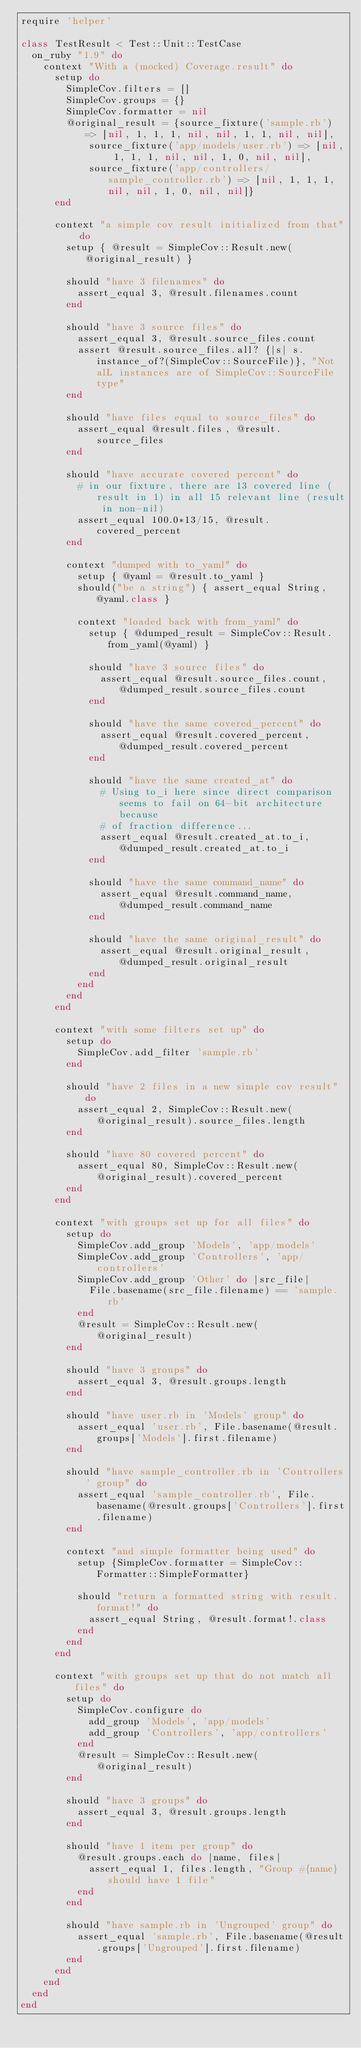<code> <loc_0><loc_0><loc_500><loc_500><_Ruby_>require 'helper'

class TestResult < Test::Unit::TestCase
  on_ruby "1.9" do
    context "With a (mocked) Coverage.result" do
      setup do
        SimpleCov.filters = []
        SimpleCov.groups = {}
        SimpleCov.formatter = nil
        @original_result = {source_fixture('sample.rb') => [nil, 1, 1, 1, nil, nil, 1, 1, nil, nil],
            source_fixture('app/models/user.rb') => [nil, 1, 1, 1, nil, nil, 1, 0, nil, nil],
            source_fixture('app/controllers/sample_controller.rb') => [nil, 1, 1, 1, nil, nil, 1, 0, nil, nil]}
      end
  
      context "a simple cov result initialized from that" do
        setup { @result = SimpleCov::Result.new(@original_result) }
    
        should "have 3 filenames" do
          assert_equal 3, @result.filenames.count
        end
    
        should "have 3 source files" do
          assert_equal 3, @result.source_files.count
          assert @result.source_files.all? {|s| s.instance_of?(SimpleCov::SourceFile)}, "Not alL instances are of SimpleCov::SourceFile type"
        end
    
        should "have files equal to source_files" do
          assert_equal @result.files, @result.source_files
        end
      
        should "have accurate covered percent" do
          # in our fixture, there are 13 covered line (result in 1) in all 15 relevant line (result in non-nil)
          assert_equal 100.0*13/15, @result.covered_percent
        end
      
        context "dumped with to_yaml" do
          setup { @yaml = @result.to_yaml }
          should("be a string") { assert_equal String, @yaml.class }
        
          context "loaded back with from_yaml" do
            setup { @dumped_result = SimpleCov::Result.from_yaml(@yaml) }
          
            should "have 3 source files" do
              assert_equal @result.source_files.count, @dumped_result.source_files.count
            end
          
            should "have the same covered_percent" do
              assert_equal @result.covered_percent, @dumped_result.covered_percent
            end
          
            should "have the same created_at" do
              # Using to_i here since direct comparison seems to fail on 64-bit architecture because
              # of fraction difference...
              assert_equal @result.created_at.to_i, @dumped_result.created_at.to_i
            end
          
            should "have the same command_name" do
              assert_equal @result.command_name, @dumped_result.command_name
            end
          
            should "have the same original_result" do
              assert_equal @result.original_result, @dumped_result.original_result
            end
          end
        end
      end
    
      context "with some filters set up" do
        setup do
          SimpleCov.add_filter 'sample.rb'
        end
      
        should "have 2 files in a new simple cov result" do
          assert_equal 2, SimpleCov::Result.new(@original_result).source_files.length
        end
      
        should "have 80 covered percent" do
          assert_equal 80, SimpleCov::Result.new(@original_result).covered_percent
        end
      end
    
      context "with groups set up for all files" do
        setup do
          SimpleCov.add_group 'Models', 'app/models'
          SimpleCov.add_group 'Controllers', 'app/controllers'
          SimpleCov.add_group 'Other' do |src_file|
            File.basename(src_file.filename) == 'sample.rb'
          end
          @result = SimpleCov::Result.new(@original_result)
        end
      
        should "have 3 groups" do
          assert_equal 3, @result.groups.length
        end
      
        should "have user.rb in 'Models' group" do
          assert_equal 'user.rb', File.basename(@result.groups['Models'].first.filename)
        end
      
        should "have sample_controller.rb in 'Controllers' group" do
          assert_equal 'sample_controller.rb', File.basename(@result.groups['Controllers'].first.filename)
        end
      
        context "and simple formatter being used" do
          setup {SimpleCov.formatter = SimpleCov::Formatter::SimpleFormatter}
        
          should "return a formatted string with result.format!" do
            assert_equal String, @result.format!.class
          end
        end
      end
  
      context "with groups set up that do not match all files" do
        setup do
          SimpleCov.configure do
            add_group 'Models', 'app/models'
            add_group 'Controllers', 'app/controllers'
          end
          @result = SimpleCov::Result.new(@original_result)
        end
      
        should "have 3 groups" do
          assert_equal 3, @result.groups.length
        end
      
        should "have 1 item per group" do
          @result.groups.each do |name, files|
            assert_equal 1, files.length, "Group #{name} should have 1 file"
          end
        end

        should "have sample.rb in 'Ungrouped' group" do
          assert_equal 'sample.rb', File.basename(@result.groups['Ungrouped'].first.filename)
        end
      end
    end
  end
end
</code> 